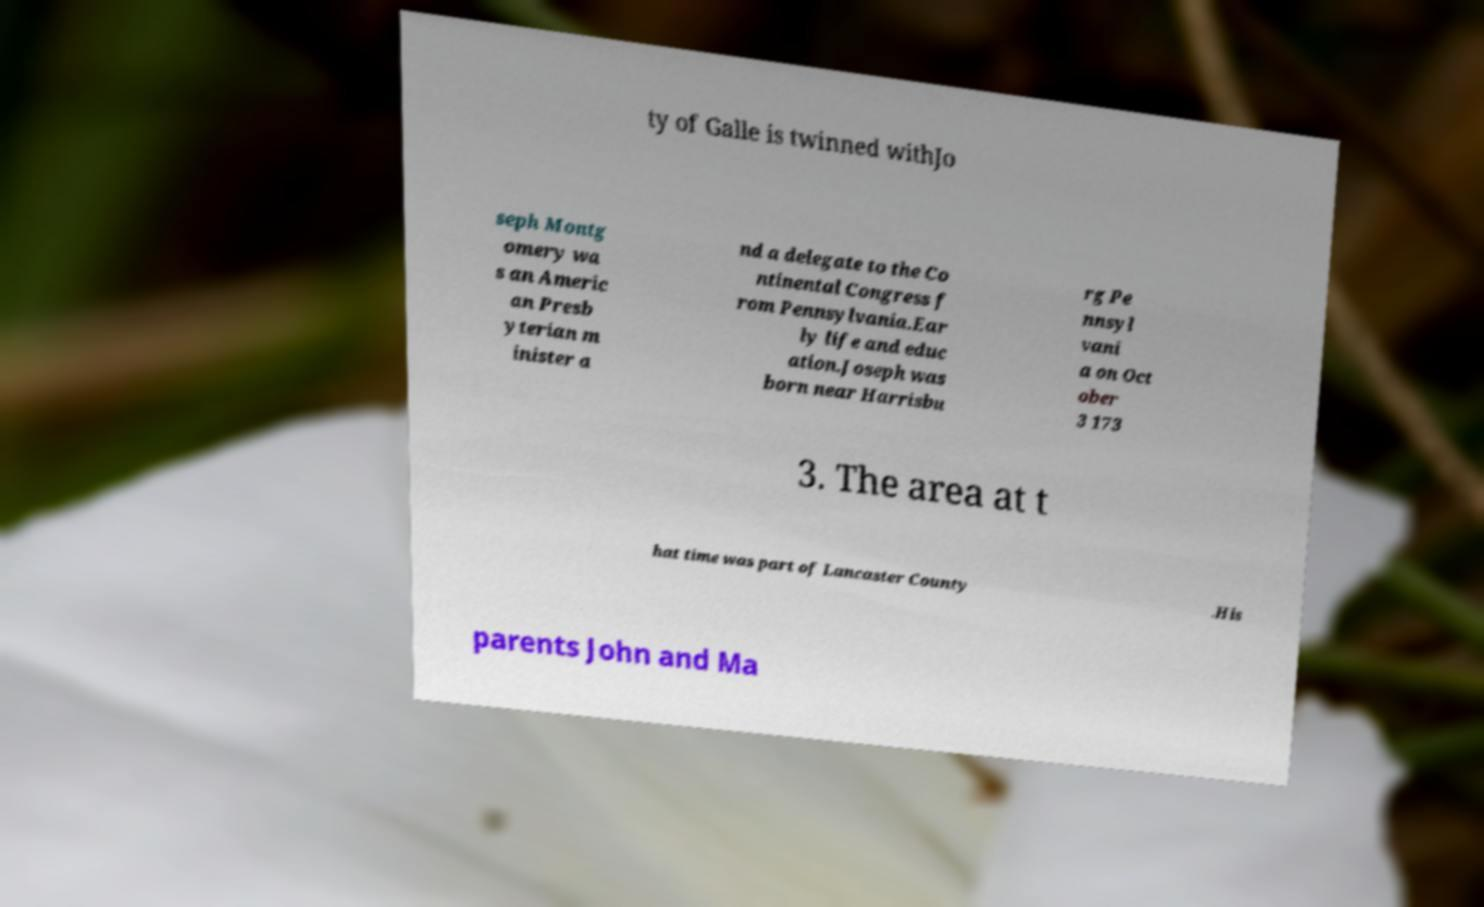There's text embedded in this image that I need extracted. Can you transcribe it verbatim? ty of Galle is twinned withJo seph Montg omery wa s an Americ an Presb yterian m inister a nd a delegate to the Co ntinental Congress f rom Pennsylvania.Ear ly life and educ ation.Joseph was born near Harrisbu rg Pe nnsyl vani a on Oct ober 3 173 3. The area at t hat time was part of Lancaster County .His parents John and Ma 